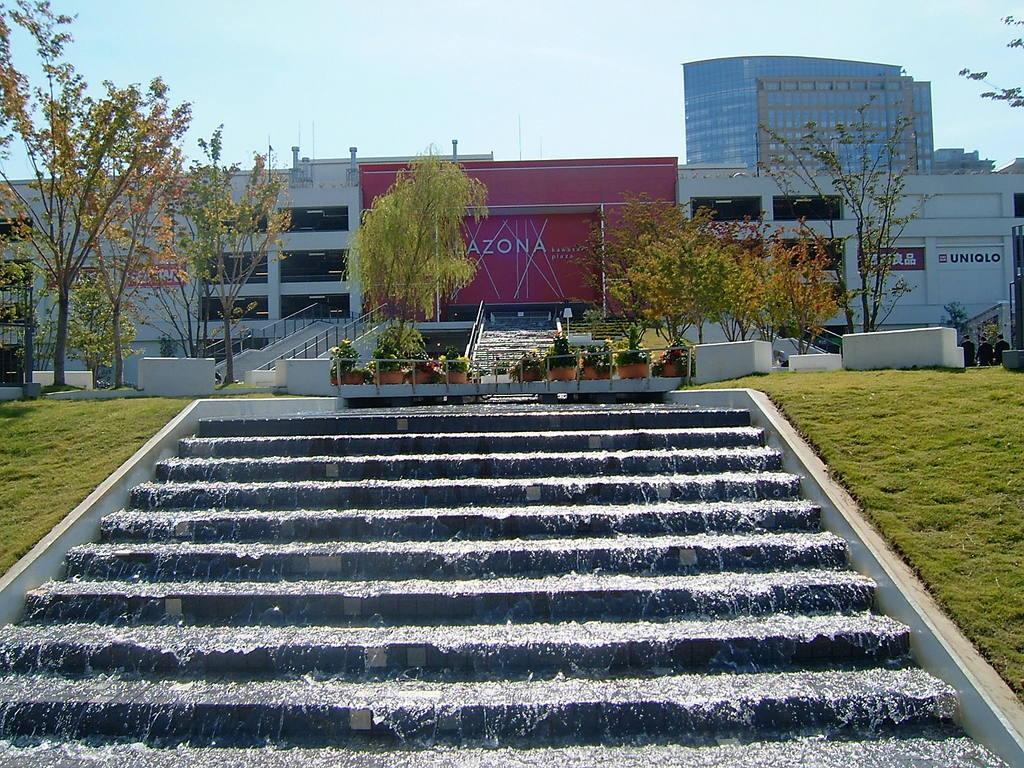Can you describe this image briefly? In this image we can see a few buildings, on the building we can see some boards with text, there are some potted plants, staircases, trees and grass, in the background we can see the sky. 